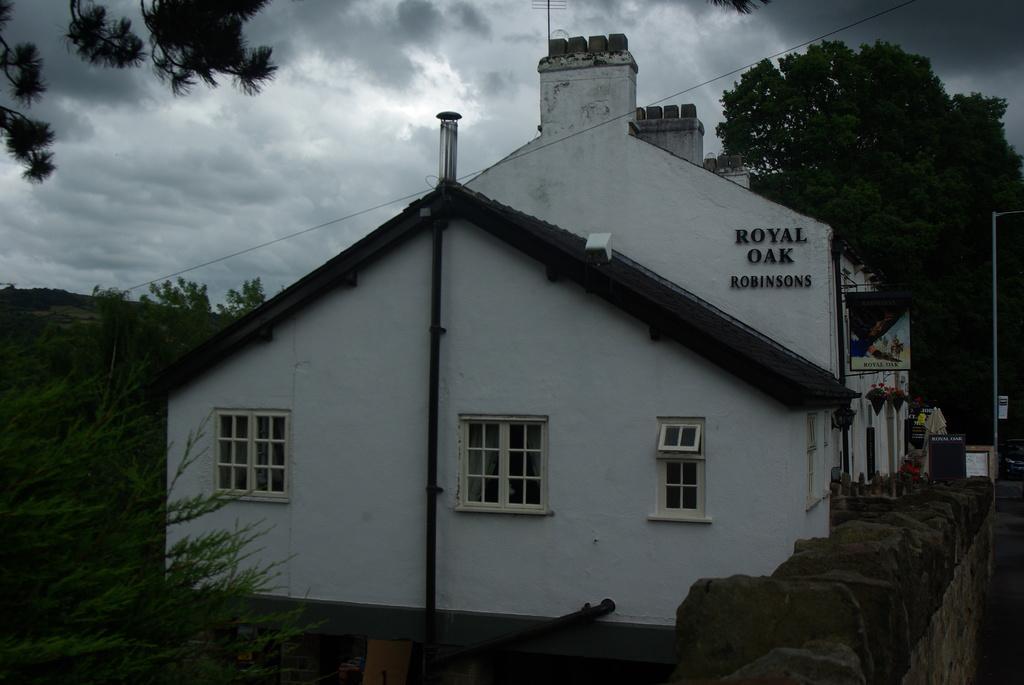In one or two sentences, can you explain what this image depicts? In this picture I can observe a house. I can observe some text on the right side on the wall. In the background there are trees and I can observe clouds in the sky. 